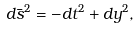Convert formula to latex. <formula><loc_0><loc_0><loc_500><loc_500>d \bar { s } ^ { 2 } = - d t ^ { 2 } + d y ^ { 2 } ,</formula> 